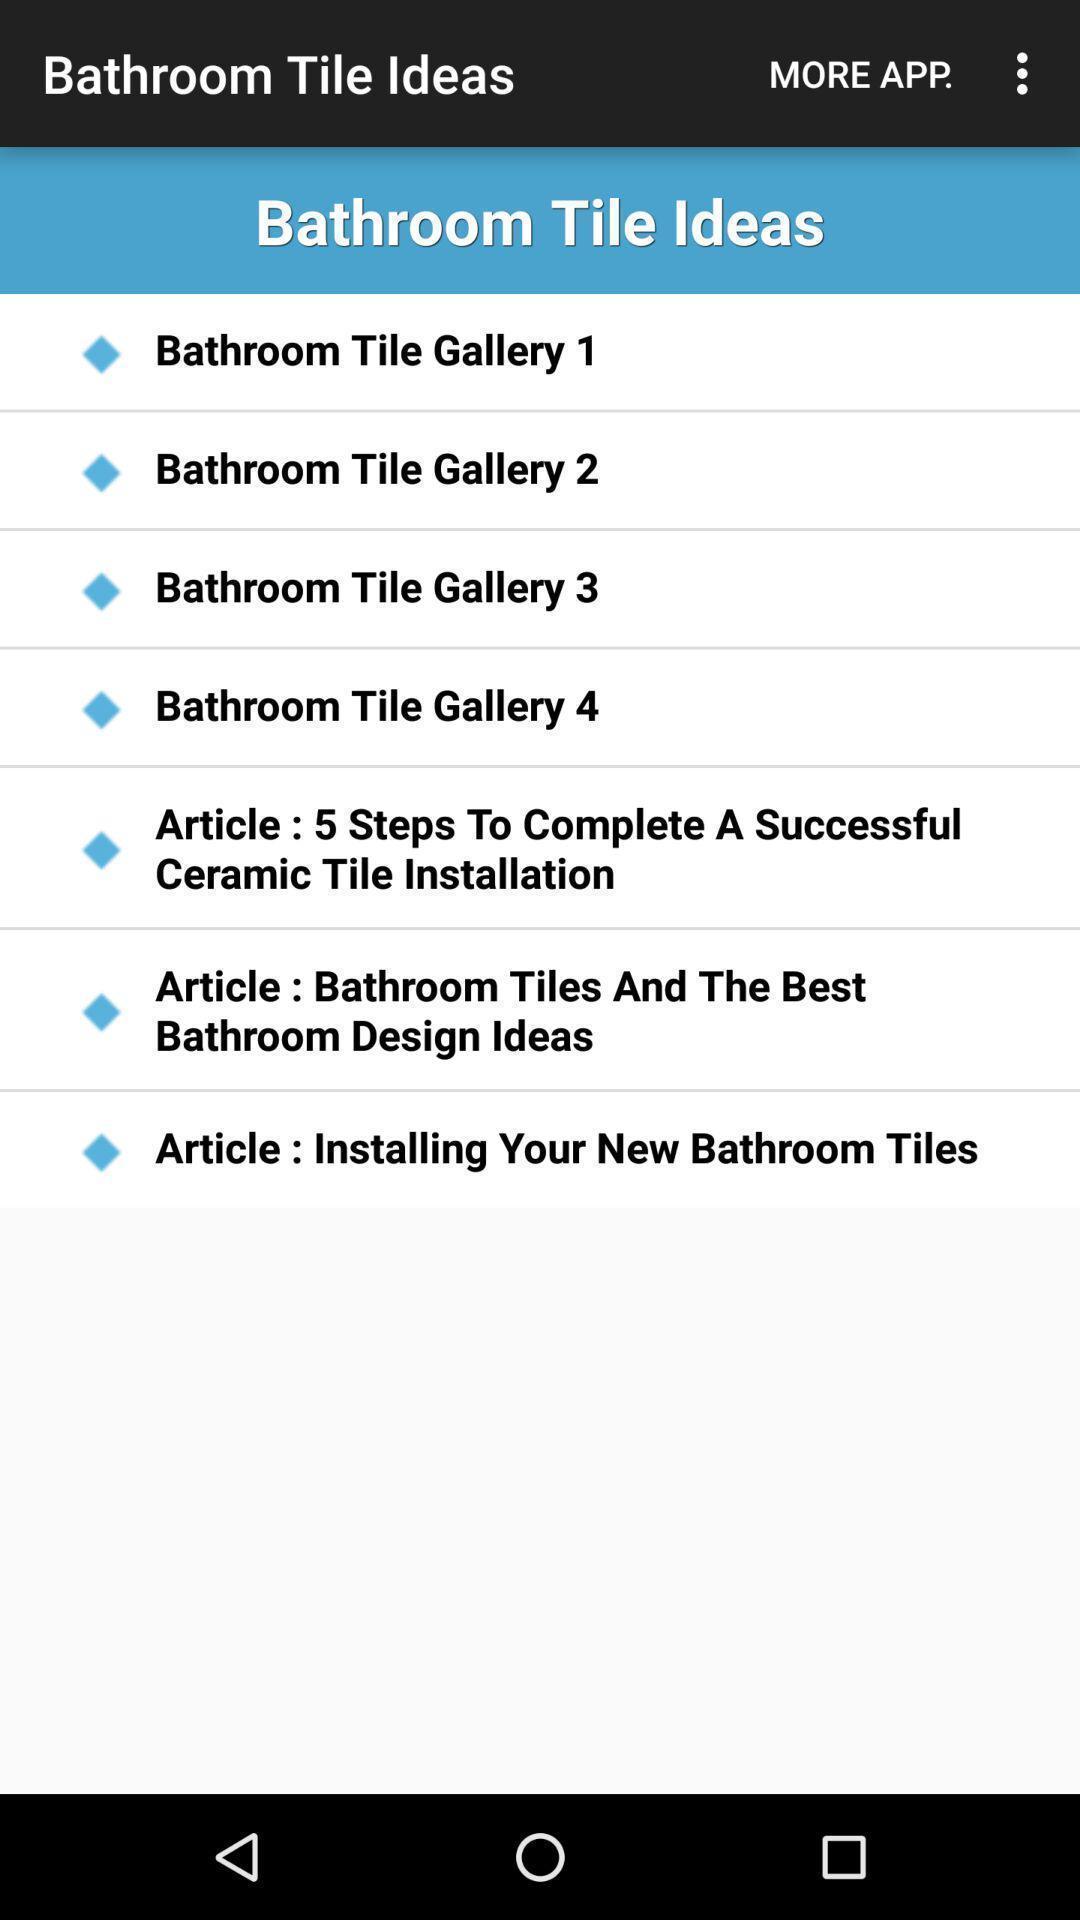Describe the visual elements of this screenshot. Screen showing ideas. 